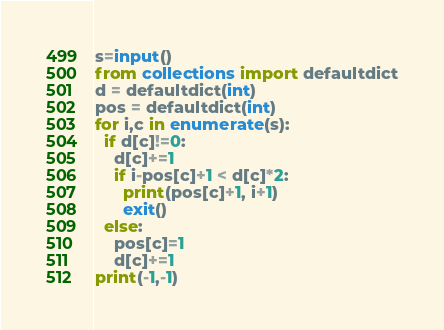<code> <loc_0><loc_0><loc_500><loc_500><_Cython_>s=input()
from collections import defaultdict
d = defaultdict(int)
pos = defaultdict(int)
for i,c in enumerate(s):
  if d[c]!=0:
    d[c]+=1
    if i-pos[c]+1 < d[c]*2:
      print(pos[c]+1, i+1)
      exit()
  else:
    pos[c]=1
    d[c]+=1
print(-1,-1)</code> 